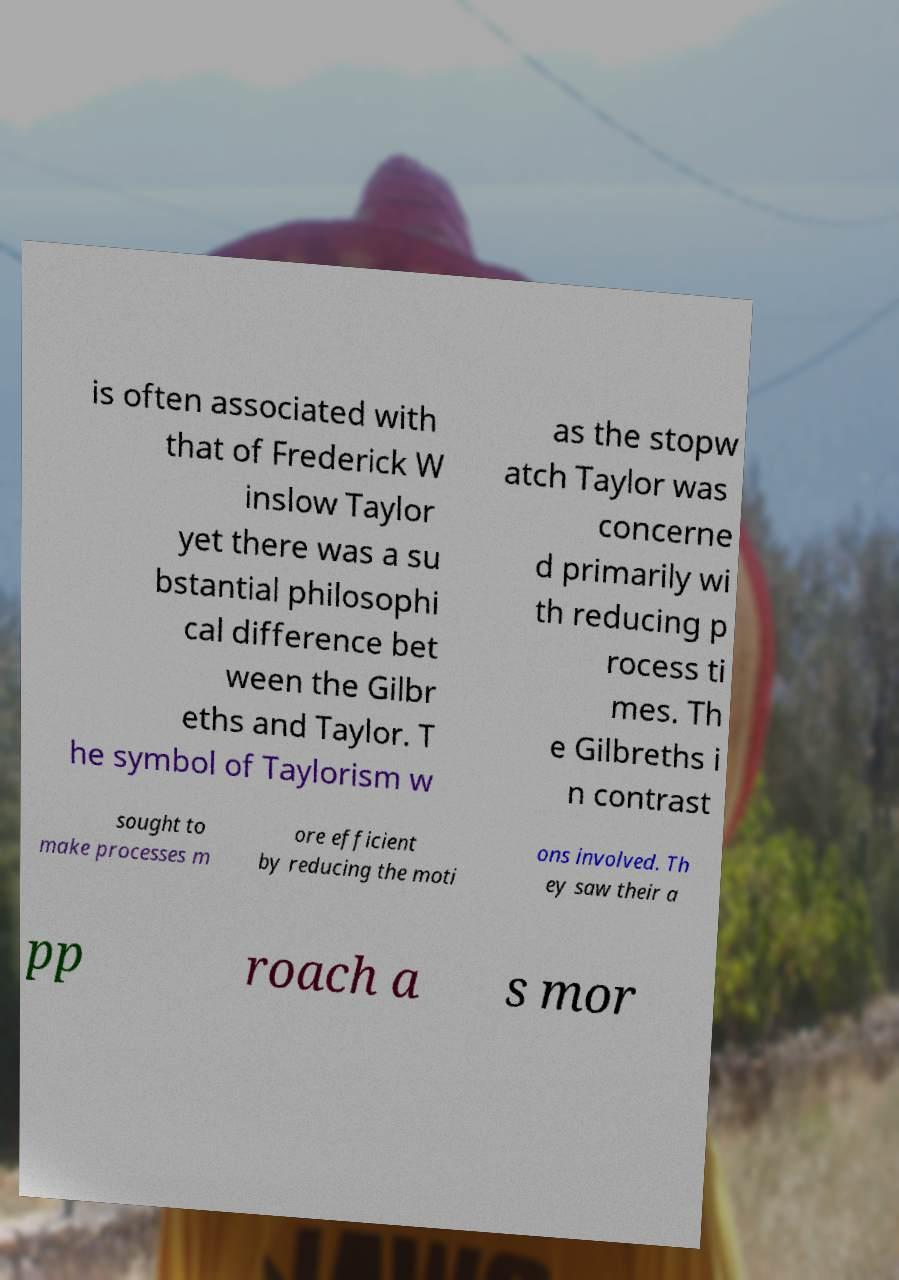Please identify and transcribe the text found in this image. is often associated with that of Frederick W inslow Taylor yet there was a su bstantial philosophi cal difference bet ween the Gilbr eths and Taylor. T he symbol of Taylorism w as the stopw atch Taylor was concerne d primarily wi th reducing p rocess ti mes. Th e Gilbreths i n contrast sought to make processes m ore efficient by reducing the moti ons involved. Th ey saw their a pp roach a s mor 